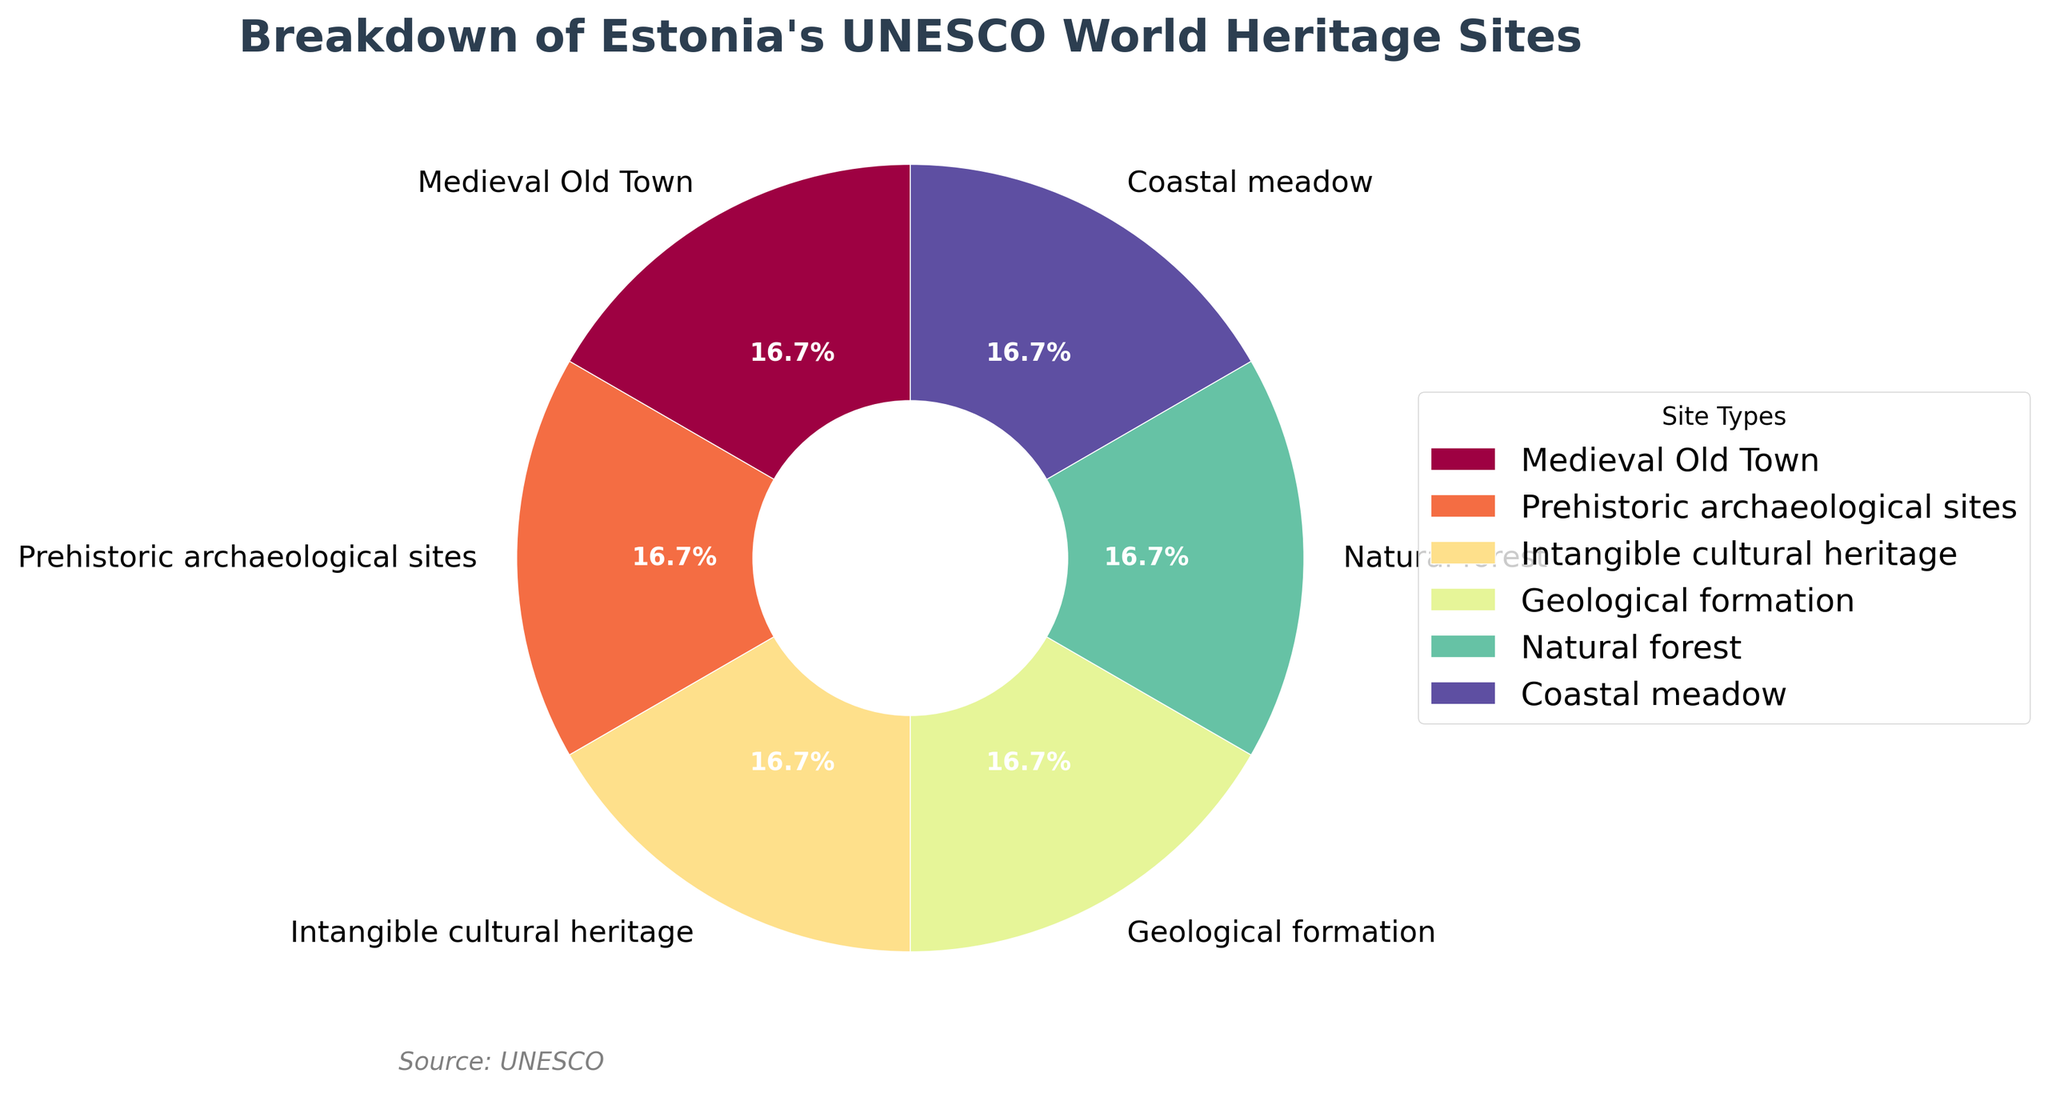How many types of UNESCO World Heritage Sites are represented in the pie chart? The pie chart labels each type of UNESCO World Heritage Site. Count the distinct labels presented in the chart.
Answer: 6 Which UNESCO World Heritage Site type has the largest slice in the pie chart? Observe the size of each wedge in the pie chart and identify which one appears the largest. Since all categories have an equal number of sites, any site should be the largest.
Answer: Any listed site What is the percentage of Intangible cultural heritage sites? Locate the segment labeled "Intangible cultural heritage" in the pie chart and refer to the percentage displayed in the wedge.
Answer: 16.7% Are there more Medieval Old Town sites or more Coastal meadow sites? Compare the wedge representing "Medieval Old Town" with the wedge representing "Coastal meadow." Since all categories are equal in number, they are the same.
Answer: Same Which color represents the Natural forest site type? Observe the color assigned to the wedge labeled "Natural forest" in the pie chart.
Answer: Dark green (or the observed color from the key) What's the total number of sites represented in the pie chart? Sum the Number of Sites for all types shown in the pie chart, which are all 1. Hence, 1+1+1+1+1+1 = 6.
Answer: 6 Find the sum of the percentage representations of Prehistoric archaeological sites and Geological formation sites. Locate the wedges for "Prehistoric archaeological sites" and "Geological formation" and sum their displayed percentages. Both are 16.7%, so 16.7% + 16.7% = 33.4%.
Answer: 33.4% Which type of site has a smaller representation: Coastal meadow or Intangible cultural heritage? Compare the wedge of "Coastal meadow" with that of "Intangible cultural heritage"; they have equal representations.
Answer: Equal How many types of sites are there that contribute to cultural heritage (Medieval Old Town, Prehistoric archaeological sites, Intangible cultural heritage)? Count the number of wedges labeled with cultural heritage-related terms: "Medieval Old Town," "Prehistoric archaeological sites," and "Intangible cultural heritage." The answer is 3 types.
Answer: 3 Of the represented UNESCO World Heritage Site types, which one looks the most similar in color to the Coastal meadow site? Visually compare the color of the wedge for "Coastal meadow" with other wedges and determine which one looks similar. This is a visual estimation.
Answer: Subjective visual estimation 